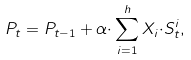Convert formula to latex. <formula><loc_0><loc_0><loc_500><loc_500>P _ { t } = P _ { t - 1 } + \alpha { \cdot } \sum _ { i = 1 } ^ { h } X _ { i } { \cdot } S ^ { i } _ { t } ,</formula> 